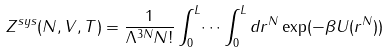<formula> <loc_0><loc_0><loc_500><loc_500>Z ^ { s y s } ( N , V , T ) = { \frac { 1 } { \Lambda ^ { 3 N } N ! } } \int _ { 0 } ^ { L } \dots \int _ { 0 } ^ { L } d r ^ { N } \exp ( - \beta U ( r ^ { N } ) )</formula> 